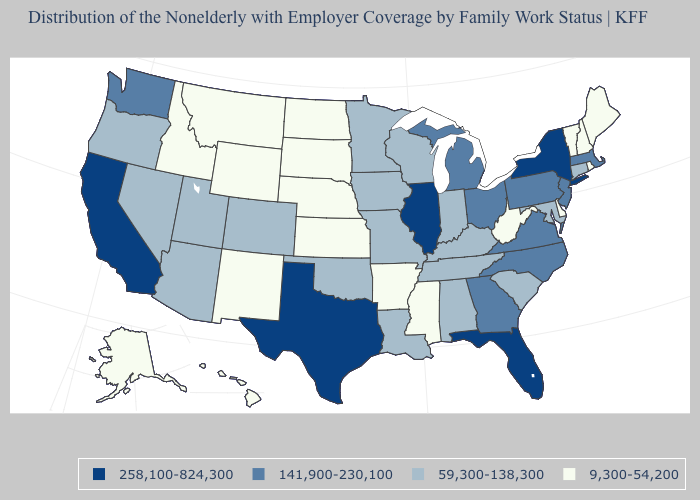Which states have the lowest value in the USA?
Write a very short answer. Alaska, Arkansas, Delaware, Hawaii, Idaho, Kansas, Maine, Mississippi, Montana, Nebraska, New Hampshire, New Mexico, North Dakota, Rhode Island, South Dakota, Vermont, West Virginia, Wyoming. Name the states that have a value in the range 258,100-824,300?
Give a very brief answer. California, Florida, Illinois, New York, Texas. What is the value of Idaho?
Give a very brief answer. 9,300-54,200. What is the value of Missouri?
Answer briefly. 59,300-138,300. Does the first symbol in the legend represent the smallest category?
Quick response, please. No. What is the value of Kansas?
Write a very short answer. 9,300-54,200. Name the states that have a value in the range 9,300-54,200?
Write a very short answer. Alaska, Arkansas, Delaware, Hawaii, Idaho, Kansas, Maine, Mississippi, Montana, Nebraska, New Hampshire, New Mexico, North Dakota, Rhode Island, South Dakota, Vermont, West Virginia, Wyoming. Among the states that border Iowa , does Nebraska have the lowest value?
Concise answer only. Yes. What is the value of Washington?
Write a very short answer. 141,900-230,100. Which states have the lowest value in the South?
Quick response, please. Arkansas, Delaware, Mississippi, West Virginia. What is the lowest value in states that border Minnesota?
Short answer required. 9,300-54,200. What is the value of Georgia?
Concise answer only. 141,900-230,100. Name the states that have a value in the range 59,300-138,300?
Short answer required. Alabama, Arizona, Colorado, Connecticut, Indiana, Iowa, Kentucky, Louisiana, Maryland, Minnesota, Missouri, Nevada, Oklahoma, Oregon, South Carolina, Tennessee, Utah, Wisconsin. Among the states that border Idaho , does Utah have the highest value?
Concise answer only. No. Name the states that have a value in the range 59,300-138,300?
Answer briefly. Alabama, Arizona, Colorado, Connecticut, Indiana, Iowa, Kentucky, Louisiana, Maryland, Minnesota, Missouri, Nevada, Oklahoma, Oregon, South Carolina, Tennessee, Utah, Wisconsin. 